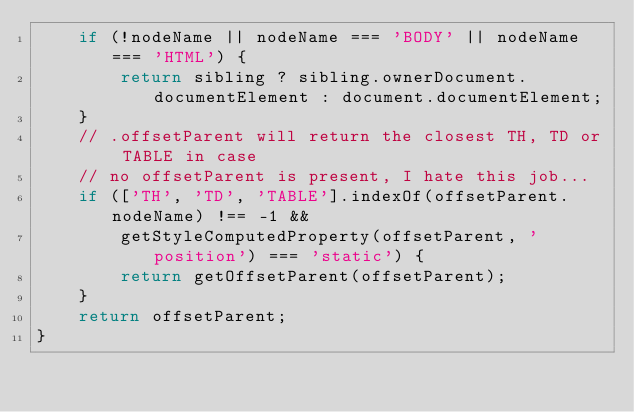<code> <loc_0><loc_0><loc_500><loc_500><_JavaScript_>    if (!nodeName || nodeName === 'BODY' || nodeName === 'HTML') {
        return sibling ? sibling.ownerDocument.documentElement : document.documentElement;
    }
    // .offsetParent will return the closest TH, TD or TABLE in case
    // no offsetParent is present, I hate this job...
    if (['TH', 'TD', 'TABLE'].indexOf(offsetParent.nodeName) !== -1 &&
        getStyleComputedProperty(offsetParent, 'position') === 'static') {
        return getOffsetParent(offsetParent);
    }
    return offsetParent;
}
</code> 